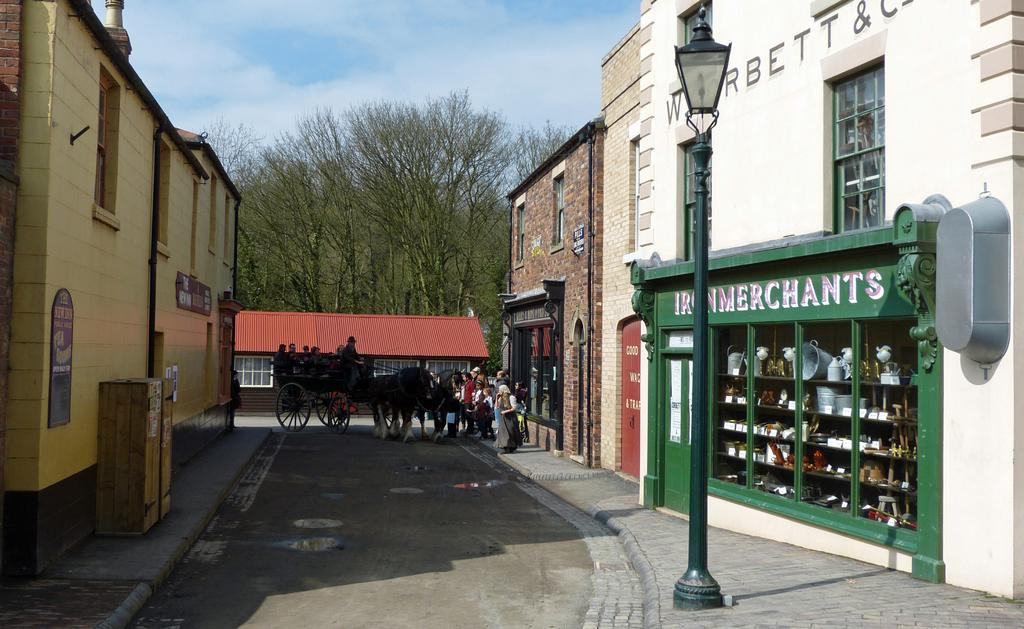<image>
Give a short and clear explanation of the subsequent image. Old town street with store front name Iron Merchants 